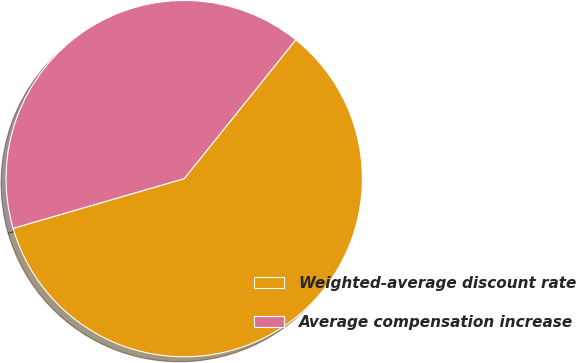Convert chart to OTSL. <chart><loc_0><loc_0><loc_500><loc_500><pie_chart><fcel>Weighted-average discount rate<fcel>Average compensation increase<nl><fcel>59.73%<fcel>40.27%<nl></chart> 